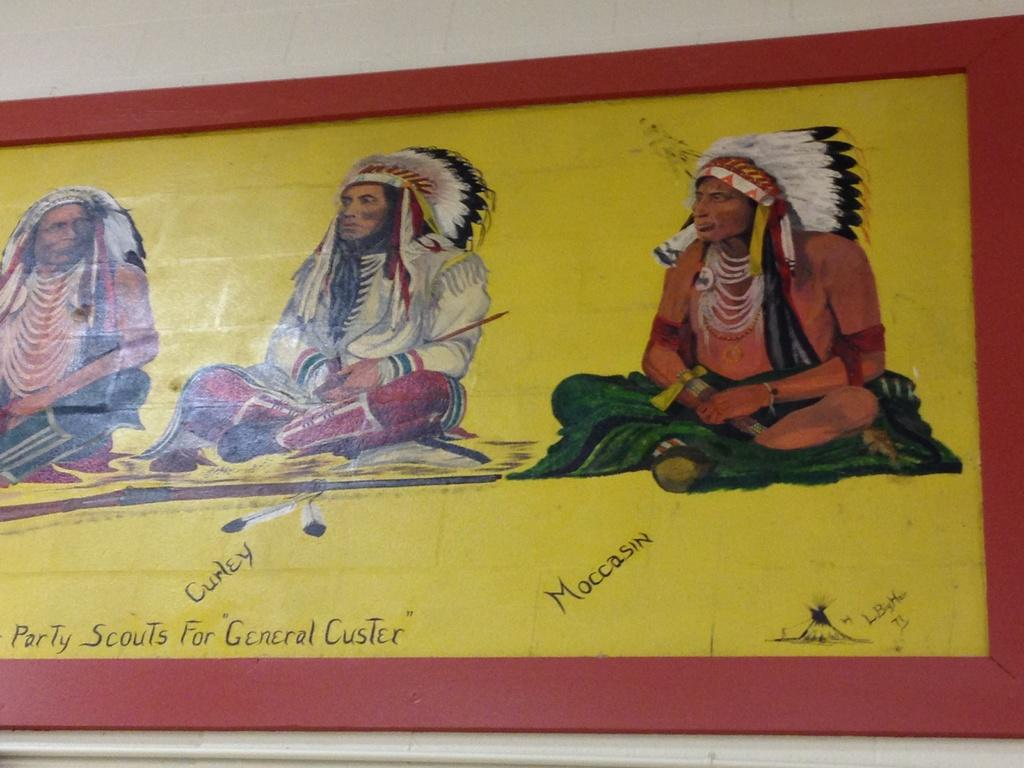What is featured on the poster in the image? There is a poster in the image, and it has a painting on it. What is the subject of the painting on the poster? The painting depicts three persons sitting. Are there any words or letters on the poster? Yes, there are texts on the poster. What color is the background of the painting on the poster? The background of the painting is white in color. What type of debt is being discussed in the painting on the poster? There is no mention of debt in the painting on the poster; it depicts three persons sitting. Is the poster located in an office setting in the image? The provided facts do not mention the location or setting of the poster in the image, so it cannot be determined if it is in an office or not. 